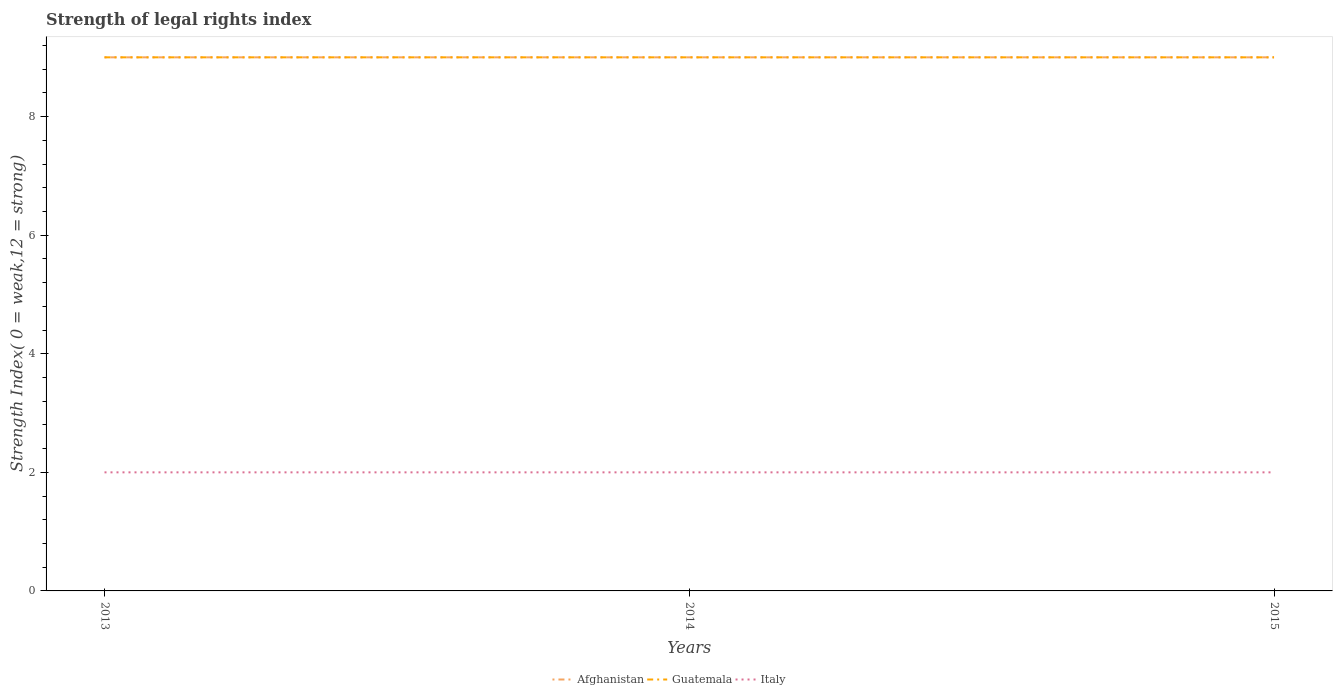How many different coloured lines are there?
Provide a short and direct response. 3. Is the number of lines equal to the number of legend labels?
Make the answer very short. Yes. Across all years, what is the maximum strength index in Guatemala?
Your answer should be very brief. 9. In which year was the strength index in Afghanistan maximum?
Provide a succinct answer. 2013. What is the total strength index in Guatemala in the graph?
Make the answer very short. 0. What is the difference between the highest and the second highest strength index in Afghanistan?
Provide a succinct answer. 0. What is the difference between the highest and the lowest strength index in Guatemala?
Ensure brevity in your answer.  0. Is the strength index in Italy strictly greater than the strength index in Afghanistan over the years?
Your answer should be compact. Yes. Are the values on the major ticks of Y-axis written in scientific E-notation?
Offer a very short reply. No. Does the graph contain any zero values?
Give a very brief answer. No. Where does the legend appear in the graph?
Offer a very short reply. Bottom center. How many legend labels are there?
Keep it short and to the point. 3. What is the title of the graph?
Your response must be concise. Strength of legal rights index. What is the label or title of the Y-axis?
Give a very brief answer. Strength Index( 0 = weak,12 = strong). What is the Strength Index( 0 = weak,12 = strong) of Guatemala in 2013?
Keep it short and to the point. 9. What is the Strength Index( 0 = weak,12 = strong) in Italy in 2013?
Offer a very short reply. 2. What is the Strength Index( 0 = weak,12 = strong) of Afghanistan in 2014?
Provide a short and direct response. 9. What is the Strength Index( 0 = weak,12 = strong) of Italy in 2014?
Your answer should be compact. 2. What is the Strength Index( 0 = weak,12 = strong) of Afghanistan in 2015?
Your answer should be compact. 9. What is the Strength Index( 0 = weak,12 = strong) in Italy in 2015?
Make the answer very short. 2. Across all years, what is the maximum Strength Index( 0 = weak,12 = strong) in Italy?
Your answer should be very brief. 2. Across all years, what is the minimum Strength Index( 0 = weak,12 = strong) of Afghanistan?
Give a very brief answer. 9. What is the difference between the Strength Index( 0 = weak,12 = strong) of Guatemala in 2013 and that in 2014?
Your response must be concise. 0. What is the difference between the Strength Index( 0 = weak,12 = strong) of Guatemala in 2014 and that in 2015?
Your answer should be compact. 0. What is the difference between the Strength Index( 0 = weak,12 = strong) in Italy in 2014 and that in 2015?
Your answer should be very brief. 0. What is the difference between the Strength Index( 0 = weak,12 = strong) in Afghanistan in 2013 and the Strength Index( 0 = weak,12 = strong) in Guatemala in 2014?
Ensure brevity in your answer.  0. What is the difference between the Strength Index( 0 = weak,12 = strong) of Guatemala in 2013 and the Strength Index( 0 = weak,12 = strong) of Italy in 2014?
Provide a succinct answer. 7. What is the difference between the Strength Index( 0 = weak,12 = strong) in Afghanistan in 2013 and the Strength Index( 0 = weak,12 = strong) in Guatemala in 2015?
Keep it short and to the point. 0. What is the difference between the Strength Index( 0 = weak,12 = strong) of Guatemala in 2013 and the Strength Index( 0 = weak,12 = strong) of Italy in 2015?
Provide a short and direct response. 7. What is the difference between the Strength Index( 0 = weak,12 = strong) of Afghanistan in 2014 and the Strength Index( 0 = weak,12 = strong) of Guatemala in 2015?
Offer a very short reply. 0. What is the difference between the Strength Index( 0 = weak,12 = strong) of Guatemala in 2014 and the Strength Index( 0 = weak,12 = strong) of Italy in 2015?
Provide a succinct answer. 7. What is the average Strength Index( 0 = weak,12 = strong) in Italy per year?
Give a very brief answer. 2. In the year 2013, what is the difference between the Strength Index( 0 = weak,12 = strong) in Afghanistan and Strength Index( 0 = weak,12 = strong) in Italy?
Provide a short and direct response. 7. In the year 2013, what is the difference between the Strength Index( 0 = weak,12 = strong) of Guatemala and Strength Index( 0 = weak,12 = strong) of Italy?
Ensure brevity in your answer.  7. In the year 2014, what is the difference between the Strength Index( 0 = weak,12 = strong) of Afghanistan and Strength Index( 0 = weak,12 = strong) of Italy?
Your answer should be very brief. 7. In the year 2014, what is the difference between the Strength Index( 0 = weak,12 = strong) in Guatemala and Strength Index( 0 = weak,12 = strong) in Italy?
Your response must be concise. 7. What is the ratio of the Strength Index( 0 = weak,12 = strong) of Afghanistan in 2013 to that in 2015?
Ensure brevity in your answer.  1. What is the ratio of the Strength Index( 0 = weak,12 = strong) of Guatemala in 2013 to that in 2015?
Your response must be concise. 1. What is the ratio of the Strength Index( 0 = weak,12 = strong) in Italy in 2013 to that in 2015?
Offer a very short reply. 1. What is the difference between the highest and the second highest Strength Index( 0 = weak,12 = strong) of Guatemala?
Provide a succinct answer. 0. What is the difference between the highest and the lowest Strength Index( 0 = weak,12 = strong) in Afghanistan?
Make the answer very short. 0. What is the difference between the highest and the lowest Strength Index( 0 = weak,12 = strong) of Italy?
Make the answer very short. 0. 